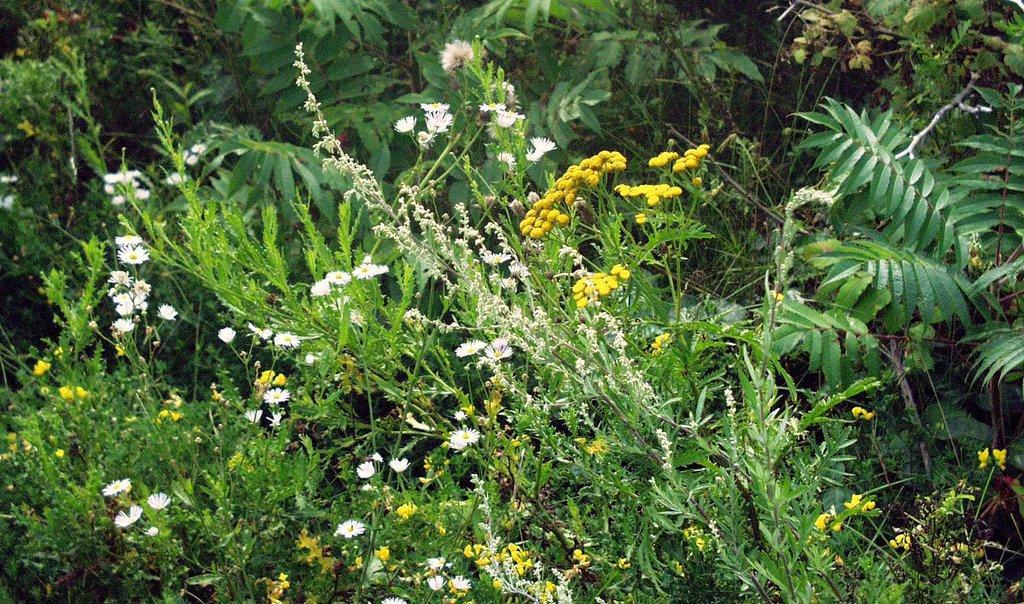How would you summarize this image in a sentence or two? Here in this picture we can see flowers present on plants and we can also see trees present over there. 